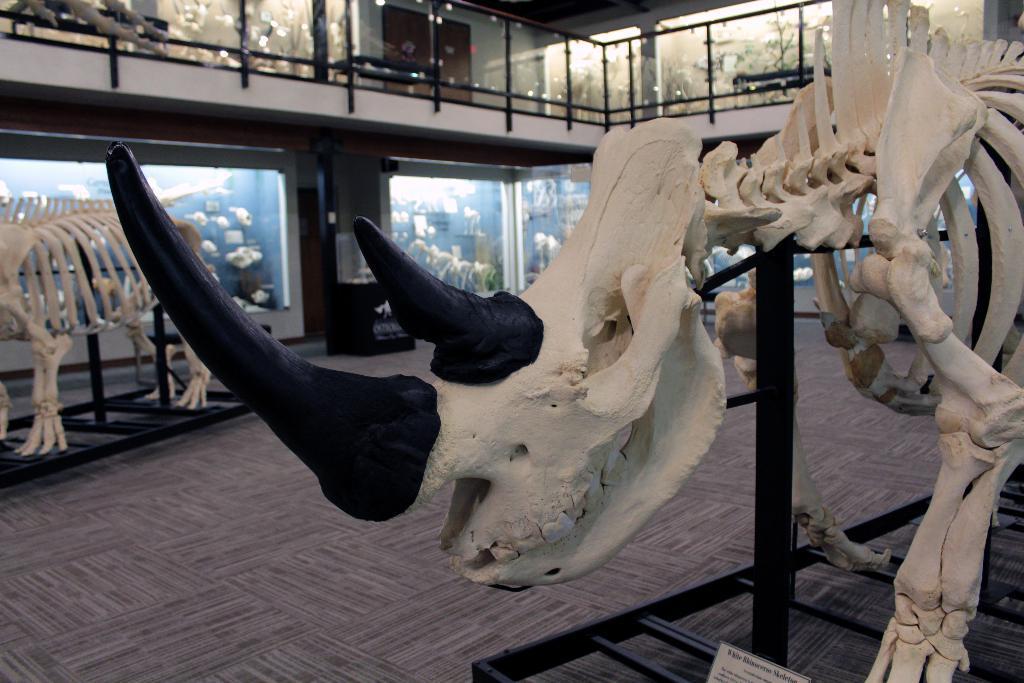How would you summarize this image in a sentence or two? On the right side, there is a skeleton of an animal arranged on a platform. On the left side, there is another skeleton of an animal on a platform, which is on the floor. In the background, there are aquariums, there is a fence and there are other objects. 